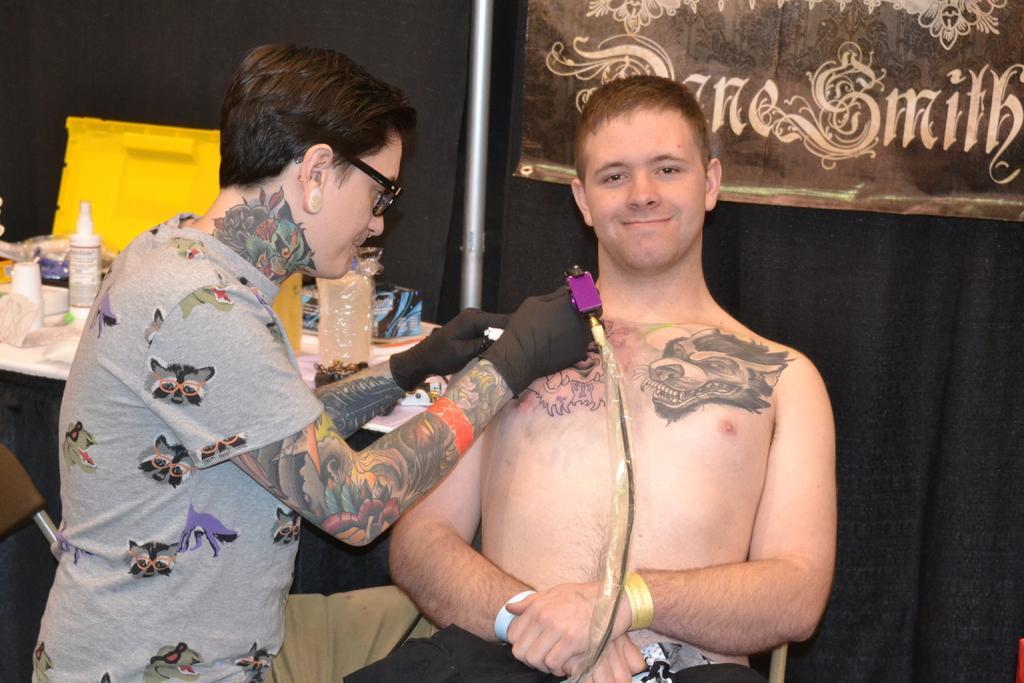Describe this image in one or two sentences. In this image there is a person doing tattoos on the other person sitting on the chair with some stuff on it, beside them there is a table with some stuff on it. In the background there are curtains and a banner with some text on it. 